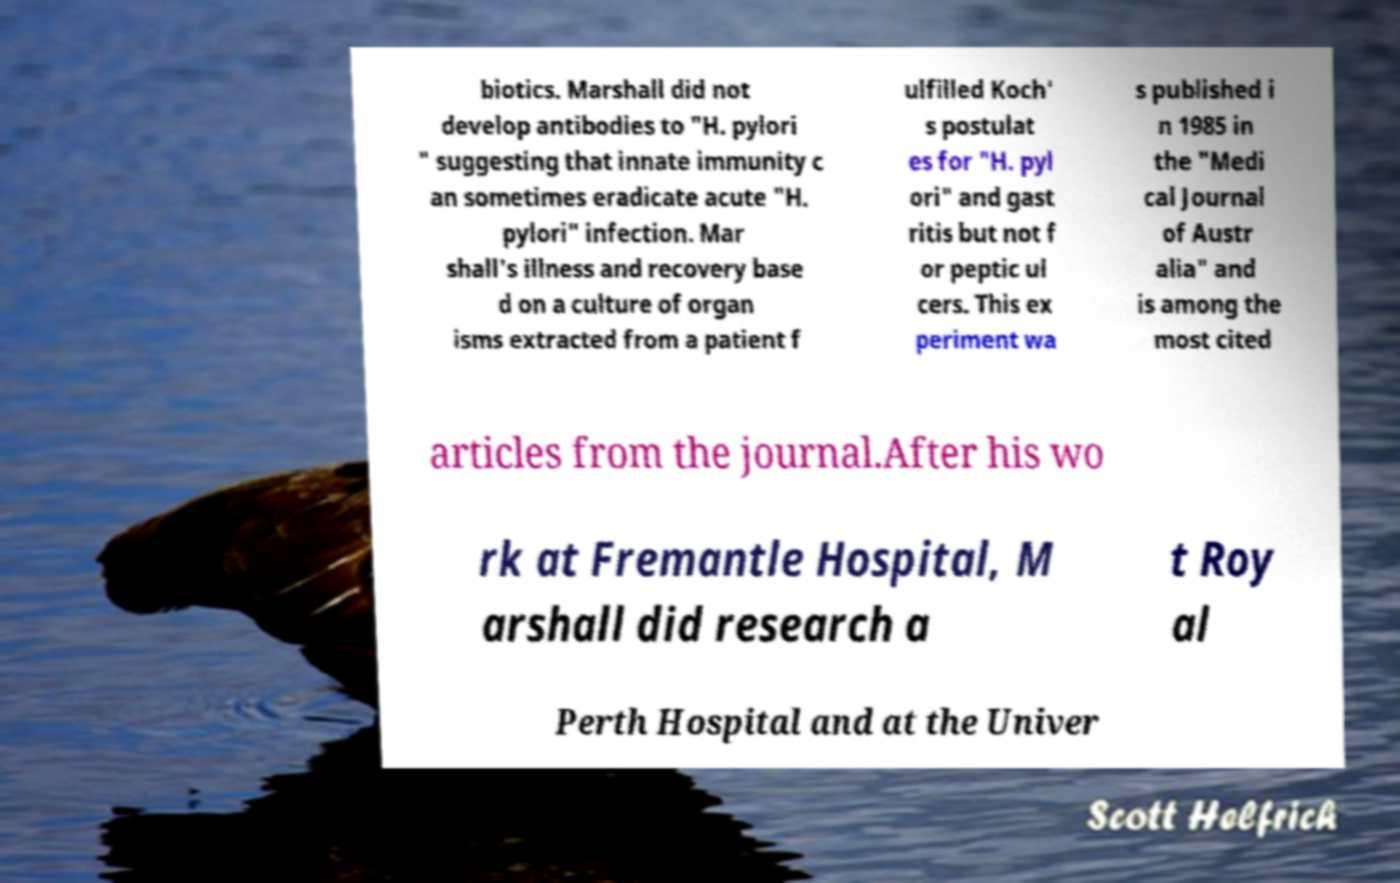Please read and relay the text visible in this image. What does it say? biotics. Marshall did not develop antibodies to "H. pylori " suggesting that innate immunity c an sometimes eradicate acute "H. pylori" infection. Mar shall's illness and recovery base d on a culture of organ isms extracted from a patient f ulfilled Koch' s postulat es for "H. pyl ori" and gast ritis but not f or peptic ul cers. This ex periment wa s published i n 1985 in the "Medi cal Journal of Austr alia" and is among the most cited articles from the journal.After his wo rk at Fremantle Hospital, M arshall did research a t Roy al Perth Hospital and at the Univer 